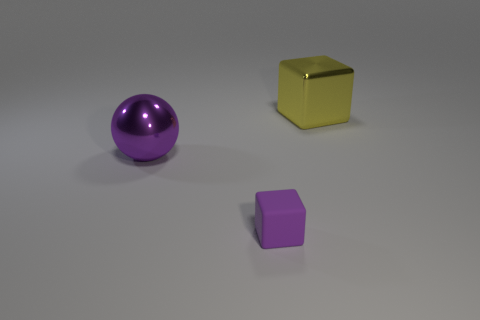Add 1 small blocks. How many objects exist? 4 Subtract 1 cubes. How many cubes are left? 1 Subtract all purple cubes. How many cubes are left? 1 Subtract all spheres. How many objects are left? 2 Subtract all purple things. Subtract all yellow metallic objects. How many objects are left? 0 Add 1 metallic cubes. How many metallic cubes are left? 2 Add 3 tiny purple matte things. How many tiny purple matte things exist? 4 Subtract 0 gray cylinders. How many objects are left? 3 Subtract all cyan cubes. Subtract all brown balls. How many cubes are left? 2 